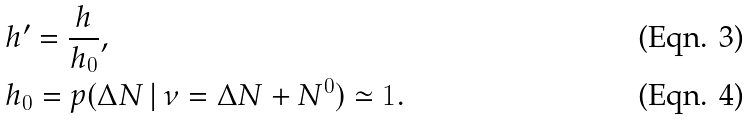Convert formula to latex. <formula><loc_0><loc_0><loc_500><loc_500>& h ^ { \prime } = \frac { h } { h _ { 0 } } , \\ & h _ { 0 } = p ( \Delta N \, | \, \nu = \Delta N + N ^ { 0 } ) \simeq 1 .</formula> 